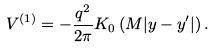Convert formula to latex. <formula><loc_0><loc_0><loc_500><loc_500>V ^ { \left ( 1 \right ) } = - \frac { q ^ { 2 } } { 2 \pi } K _ { 0 } \left ( { M | { y } - { y } ^ { \prime } | } \right ) .</formula> 